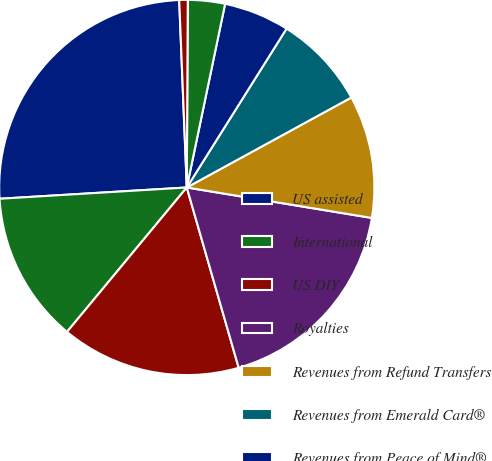<chart> <loc_0><loc_0><loc_500><loc_500><pie_chart><fcel>US assisted<fcel>International<fcel>US DIY<fcel>Royalties<fcel>Revenues from Refund Transfers<fcel>Revenues from Emerald Card®<fcel>Revenues from Peace of Mind®<fcel>Interest and fee income on<fcel>Other<nl><fcel>25.31%<fcel>13.02%<fcel>15.48%<fcel>17.94%<fcel>10.56%<fcel>8.11%<fcel>5.65%<fcel>3.19%<fcel>0.73%<nl></chart> 